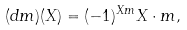Convert formula to latex. <formula><loc_0><loc_0><loc_500><loc_500>( d m ) ( X ) = ( - 1 ) ^ { X m } X \cdot m ,</formula> 